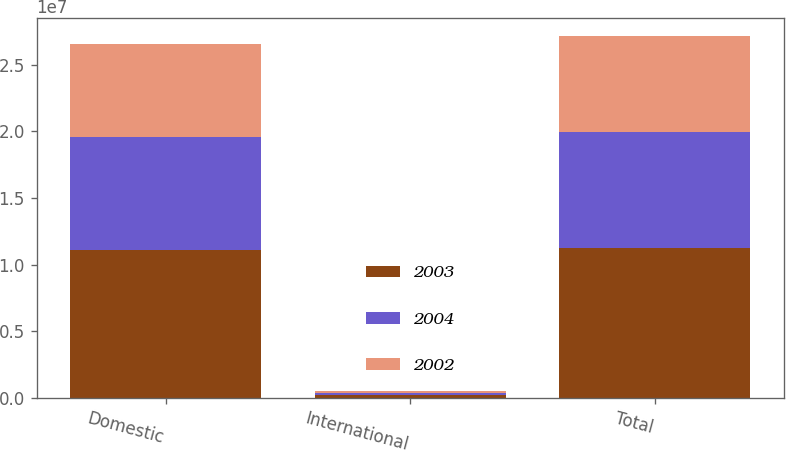Convert chart to OTSL. <chart><loc_0><loc_0><loc_500><loc_500><stacked_bar_chart><ecel><fcel>Domestic<fcel>International<fcel>Total<nl><fcel>2003<fcel>1.10946e+07<fcel>196740<fcel>1.12914e+07<nl><fcel>2004<fcel>8.48234e+06<fcel>191125<fcel>8.67347e+06<nl><fcel>2002<fcel>6.99161e+06<fcel>170195<fcel>7.16181e+06<nl></chart> 